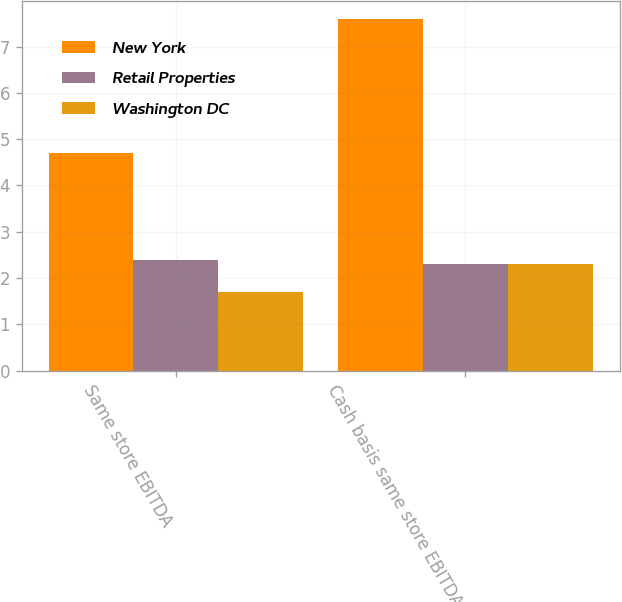Convert chart. <chart><loc_0><loc_0><loc_500><loc_500><stacked_bar_chart><ecel><fcel>Same store EBITDA<fcel>Cash basis same store EBITDA<nl><fcel>New York<fcel>4.7<fcel>7.6<nl><fcel>Retail Properties<fcel>2.4<fcel>2.3<nl><fcel>Washington DC<fcel>1.7<fcel>2.3<nl></chart> 